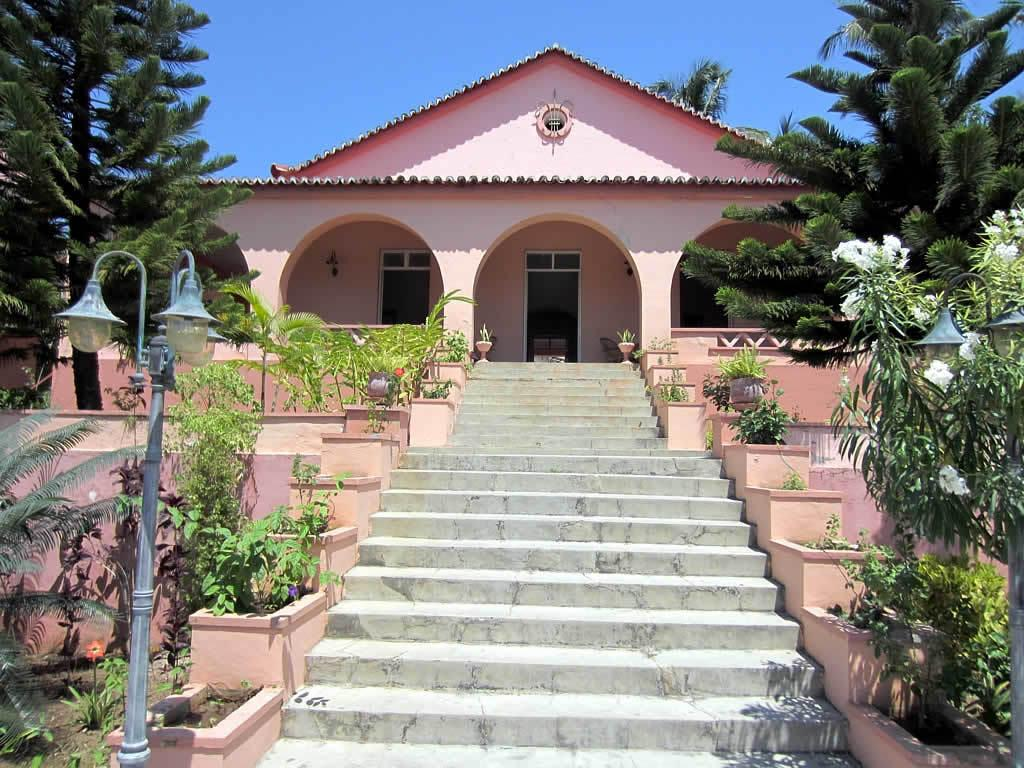What type of vegetation can be seen in the image? There are trees in the image. What color are the trees? The trees are green. What structure is present in the image? There is a light pole in the image. What can be seen in the background of the image? There is a building in the background of the image. What color is the building? The building is pink. What is the color of the sky in the image? The sky is blue. Can you see a tray being used to carry items in the image? There is no tray present in the image. How many quarters can be seen on the ground in the image? There are no quarters visible in the image. 